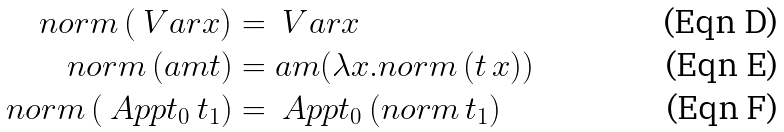Convert formula to latex. <formula><loc_0><loc_0><loc_500><loc_500>n o r m \, ( \ V a r x ) & = \ V a r x \\ n o r m \, ( \L a m t ) & = \L a m ( \lambda x . n o r m \, ( t \, x ) ) \\ n o r m \, ( \ A p p t _ { 0 } \, t _ { 1 } ) & = \ A p p t _ { 0 } \, ( n o r m \, t _ { 1 } )</formula> 